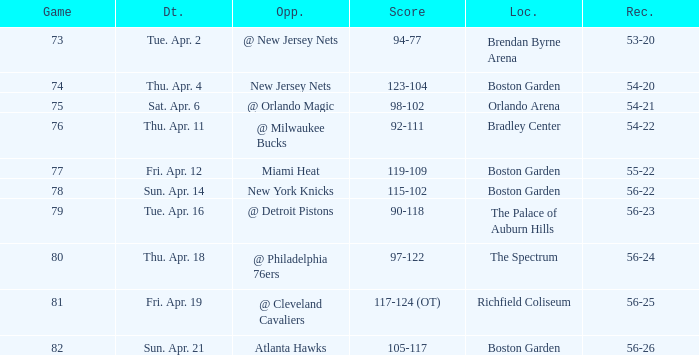Which Score has a Location of richfield coliseum? 117-124 (OT). 